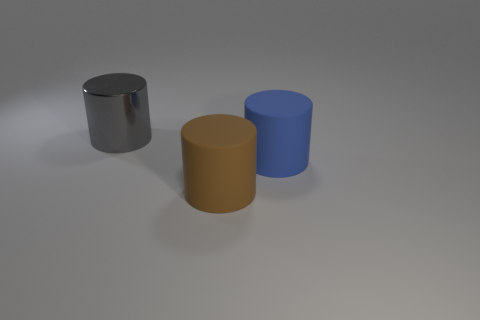What color is the other shiny cylinder that is the same size as the blue cylinder?
Give a very brief answer. Gray. There is another big shiny thing that is the same shape as the large brown object; what color is it?
Keep it short and to the point. Gray. What number of objects are blue rubber objects or things in front of the big metallic object?
Ensure brevity in your answer.  2. Is the number of big gray metallic cylinders to the left of the metal thing less than the number of blue spheres?
Offer a very short reply. No. There is a rubber cylinder behind the rubber cylinder in front of the cylinder that is right of the big brown rubber cylinder; how big is it?
Provide a succinct answer. Large. There is a cylinder that is behind the brown object and on the right side of the gray metal object; what color is it?
Provide a succinct answer. Blue. What number of large cubes are there?
Your response must be concise. 0. Does the brown cylinder have the same material as the blue cylinder?
Offer a terse response. Yes. Is the size of the cylinder behind the large blue rubber object the same as the object that is in front of the large blue rubber cylinder?
Offer a very short reply. Yes. Are there fewer big blue matte things than small purple rubber spheres?
Your answer should be very brief. No. 